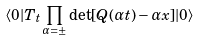<formula> <loc_0><loc_0><loc_500><loc_500>\langle 0 | T _ { t } \prod _ { \alpha = \pm } \det [ { Q } ( \alpha t ) - \alpha x ] | 0 \rangle</formula> 